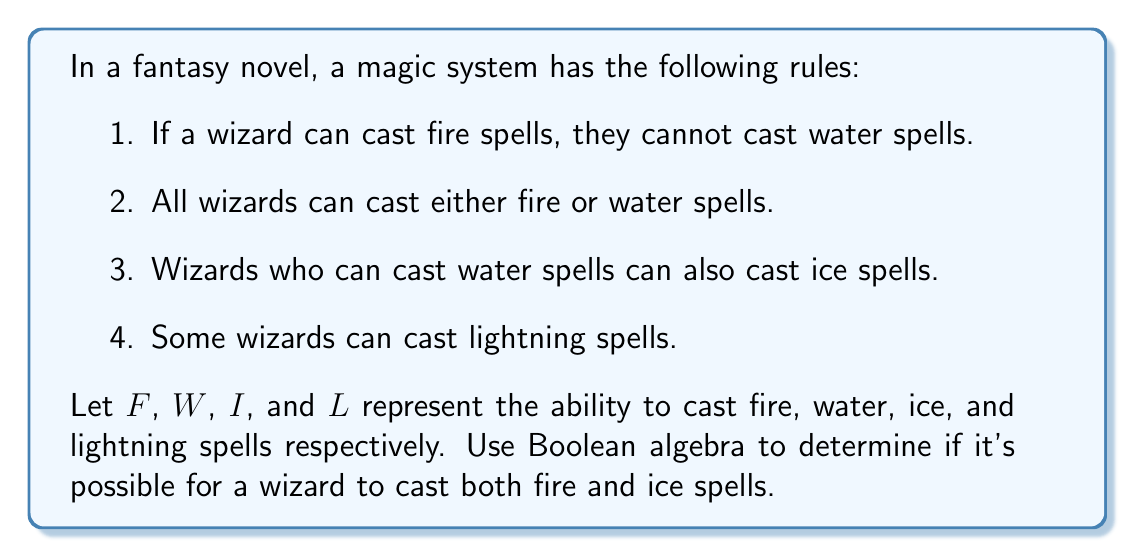Could you help me with this problem? Let's approach this step-by-step using Boolean algebra:

1. From rule 1, we can write: $F \implies \neg W$ (if fire, then not water)

2. Rule 2 can be expressed as: $F \lor W$ (every wizard can cast either fire or water)

3. Rule 3 gives us: $W \implies I$ (if water, then ice)

4. We don't need to use rule 4 for this problem.

Now, let's solve the problem:

a) Assume a wizard can cast both fire and ice spells: $F \land I$

b) From rule 3, we know that ice implies water: $I \implies W$

c) So, if a wizard can cast ice spells, they must be able to cast water spells: $F \land I \implies F \land W$

d) However, from rule 1, we know that $F \implies \neg W$

e) This creates a contradiction: $F \land W \land (F \implies \neg W)$

f) In Boolean algebra, this evaluates to false: $F \land W \land (\neg F \lor \neg W) = F \land W \land \neg W = 0$

Therefore, it's not possible for a wizard to cast both fire and ice spells in this magic system.
Answer: No 